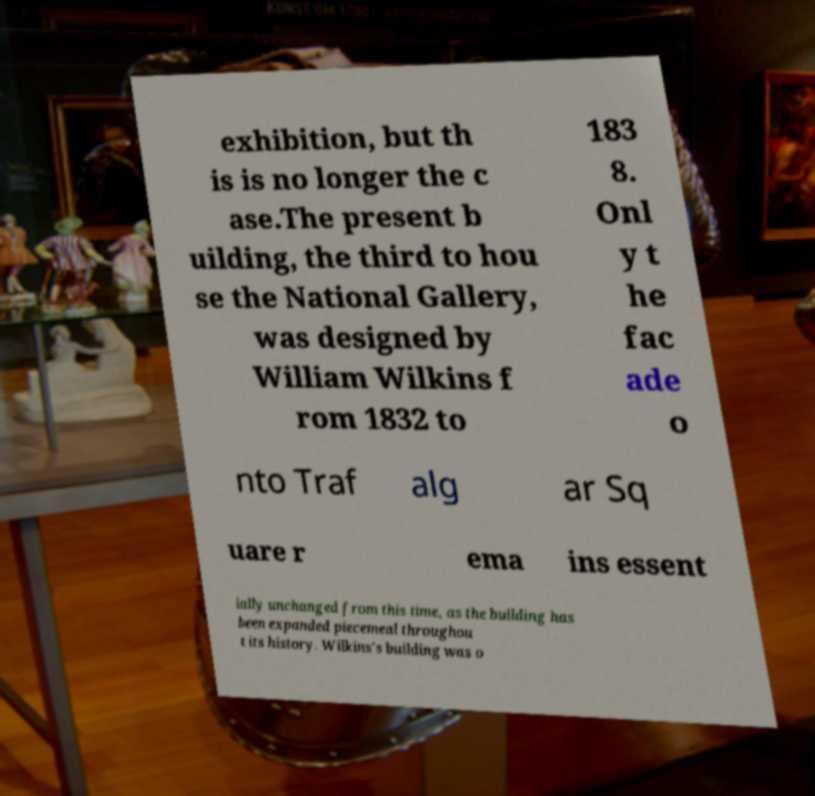Can you read and provide the text displayed in the image?This photo seems to have some interesting text. Can you extract and type it out for me? exhibition, but th is is no longer the c ase.The present b uilding, the third to hou se the National Gallery, was designed by William Wilkins f rom 1832 to 183 8. Onl y t he fac ade o nto Traf alg ar Sq uare r ema ins essent ially unchanged from this time, as the building has been expanded piecemeal throughou t its history. Wilkins's building was o 